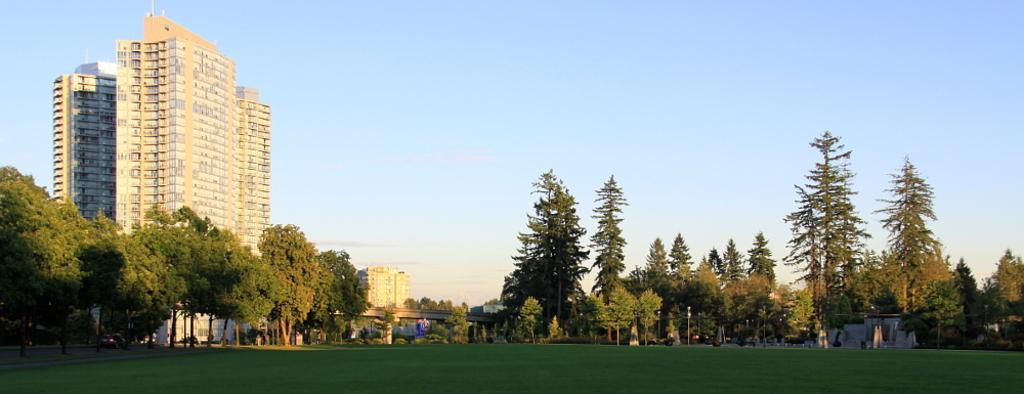Could you give a brief overview of what you see in this image? In this picture we can see a few buildings, poles and trees. Some grass is visible on the ground. 